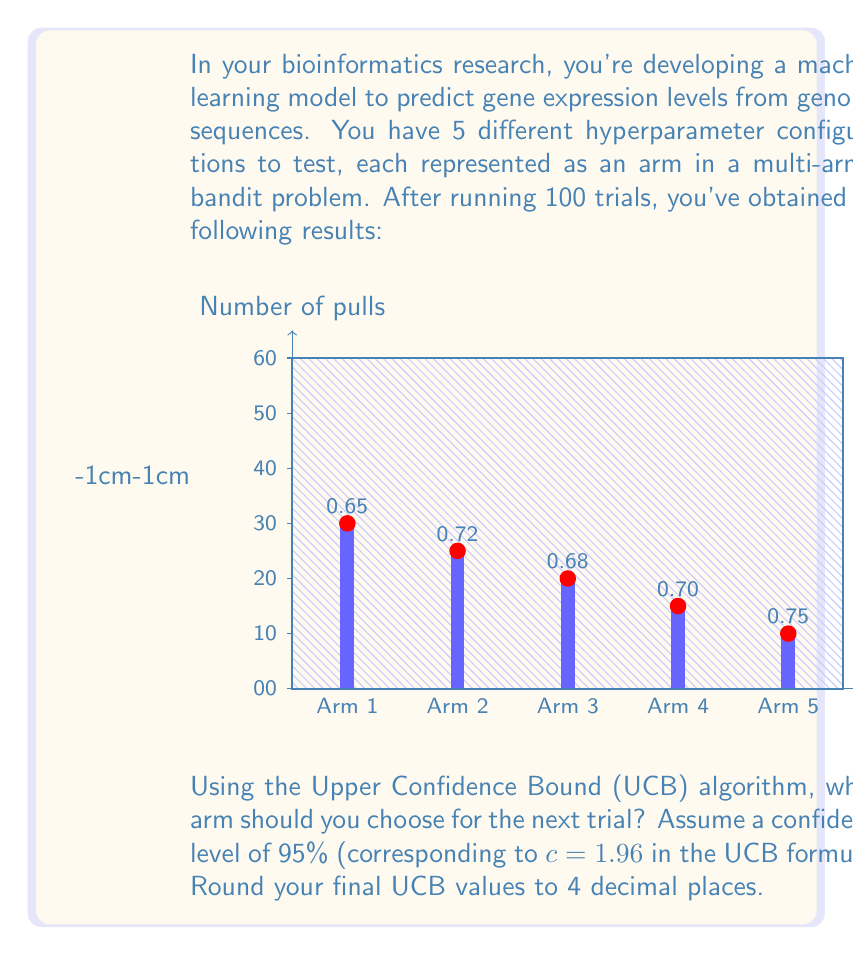Can you solve this math problem? To solve this multi-armed bandit problem using the Upper Confidence Bound (UCB) algorithm, we'll follow these steps:

1) The UCB formula is:

   $$UCB_i = \bar{X}_i + c\sqrt{\frac{2\ln{n}}{n_i}}$$

   Where:
   - $\bar{X}_i$ is the average reward for arm $i$
   - $c$ is the exploration parameter (1.96 for 95% confidence)
   - $n$ is the total number of trials (100 in this case)
   - $n_i$ is the number of times arm $i$ has been pulled

2) Calculate the UCB value for each arm:

   Arm 1: $UCB_1 = 0.65 + 1.96\sqrt{\frac{2\ln{100}}{30}} = 0.65 + 0.3533 = 1.0033$

   Arm 2: $UCB_2 = 0.72 + 1.96\sqrt{\frac{2\ln{100}}{25}} = 0.72 + 0.3874 = 1.1074$

   Arm 3: $UCB_3 = 0.68 + 1.96\sqrt{\frac{2\ln{100}}{20}} = 0.68 + 0.4330 = 1.1130$

   Arm 4: $UCB_4 = 0.70 + 1.96\sqrt{\frac{2\ln{100}}{15}} = 0.70 + 0.5002 = 1.2002$

   Arm 5: $UCB_5 = 0.75 + 1.96\sqrt{\frac{2\ln{100}}{10}} = 0.75 + 0.6128 = 1.3628$

3) Choose the arm with the highest UCB value.

   The highest UCB value is 1.3628, corresponding to Arm 5.
Answer: Arm 5 (UCB = 1.3628) 